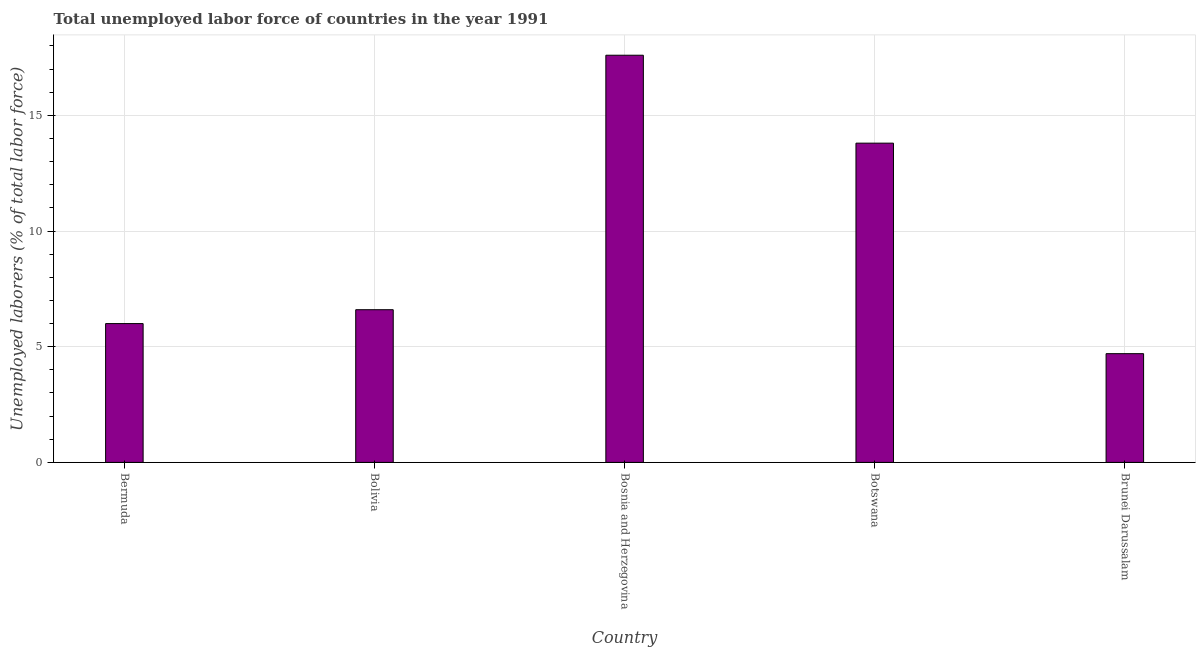Does the graph contain any zero values?
Offer a very short reply. No. What is the title of the graph?
Make the answer very short. Total unemployed labor force of countries in the year 1991. What is the label or title of the Y-axis?
Make the answer very short. Unemployed laborers (% of total labor force). What is the total unemployed labour force in Bosnia and Herzegovina?
Provide a short and direct response. 17.6. Across all countries, what is the maximum total unemployed labour force?
Provide a short and direct response. 17.6. Across all countries, what is the minimum total unemployed labour force?
Offer a terse response. 4.7. In which country was the total unemployed labour force maximum?
Ensure brevity in your answer.  Bosnia and Herzegovina. In which country was the total unemployed labour force minimum?
Your answer should be very brief. Brunei Darussalam. What is the sum of the total unemployed labour force?
Offer a terse response. 48.7. What is the average total unemployed labour force per country?
Your response must be concise. 9.74. What is the median total unemployed labour force?
Your answer should be very brief. 6.6. What is the ratio of the total unemployed labour force in Botswana to that in Brunei Darussalam?
Your answer should be very brief. 2.94. Is the sum of the total unemployed labour force in Bolivia and Brunei Darussalam greater than the maximum total unemployed labour force across all countries?
Offer a terse response. No. What is the difference between two consecutive major ticks on the Y-axis?
Your answer should be very brief. 5. Are the values on the major ticks of Y-axis written in scientific E-notation?
Keep it short and to the point. No. What is the Unemployed laborers (% of total labor force) of Bermuda?
Keep it short and to the point. 6. What is the Unemployed laborers (% of total labor force) of Bolivia?
Ensure brevity in your answer.  6.6. What is the Unemployed laborers (% of total labor force) of Bosnia and Herzegovina?
Provide a succinct answer. 17.6. What is the Unemployed laborers (% of total labor force) of Botswana?
Offer a terse response. 13.8. What is the Unemployed laborers (% of total labor force) of Brunei Darussalam?
Offer a very short reply. 4.7. What is the difference between the Unemployed laborers (% of total labor force) in Bermuda and Bosnia and Herzegovina?
Provide a short and direct response. -11.6. What is the difference between the Unemployed laborers (% of total labor force) in Bermuda and Botswana?
Provide a succinct answer. -7.8. What is the difference between the Unemployed laborers (% of total labor force) in Bolivia and Botswana?
Offer a very short reply. -7.2. What is the difference between the Unemployed laborers (% of total labor force) in Bolivia and Brunei Darussalam?
Your response must be concise. 1.9. What is the ratio of the Unemployed laborers (% of total labor force) in Bermuda to that in Bolivia?
Make the answer very short. 0.91. What is the ratio of the Unemployed laborers (% of total labor force) in Bermuda to that in Bosnia and Herzegovina?
Provide a succinct answer. 0.34. What is the ratio of the Unemployed laborers (% of total labor force) in Bermuda to that in Botswana?
Give a very brief answer. 0.43. What is the ratio of the Unemployed laborers (% of total labor force) in Bermuda to that in Brunei Darussalam?
Your answer should be compact. 1.28. What is the ratio of the Unemployed laborers (% of total labor force) in Bolivia to that in Botswana?
Provide a succinct answer. 0.48. What is the ratio of the Unemployed laborers (% of total labor force) in Bolivia to that in Brunei Darussalam?
Provide a short and direct response. 1.4. What is the ratio of the Unemployed laborers (% of total labor force) in Bosnia and Herzegovina to that in Botswana?
Provide a succinct answer. 1.27. What is the ratio of the Unemployed laborers (% of total labor force) in Bosnia and Herzegovina to that in Brunei Darussalam?
Keep it short and to the point. 3.75. What is the ratio of the Unemployed laborers (% of total labor force) in Botswana to that in Brunei Darussalam?
Give a very brief answer. 2.94. 